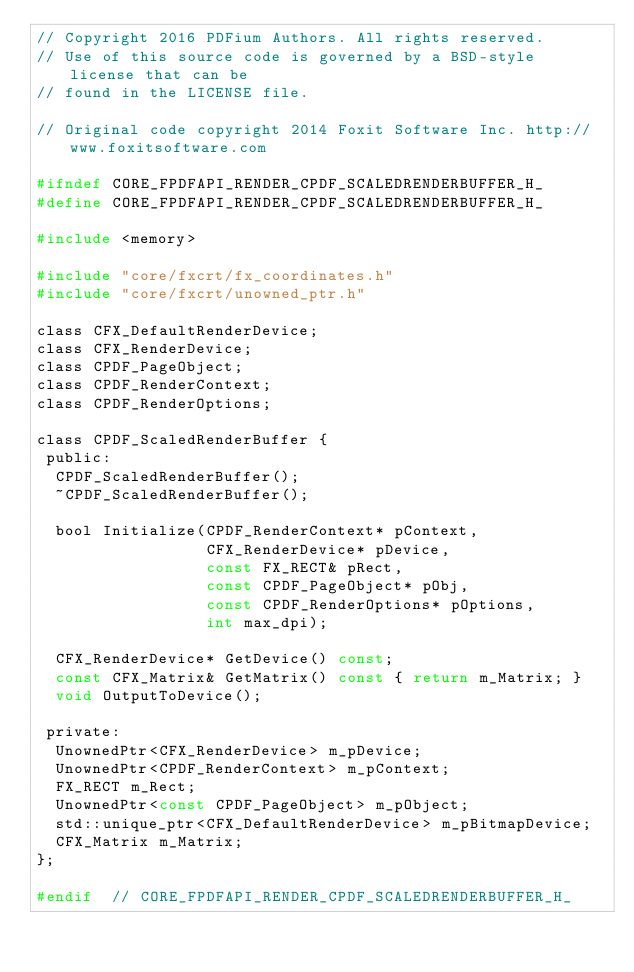Convert code to text. <code><loc_0><loc_0><loc_500><loc_500><_C_>// Copyright 2016 PDFium Authors. All rights reserved.
// Use of this source code is governed by a BSD-style license that can be
// found in the LICENSE file.

// Original code copyright 2014 Foxit Software Inc. http://www.foxitsoftware.com

#ifndef CORE_FPDFAPI_RENDER_CPDF_SCALEDRENDERBUFFER_H_
#define CORE_FPDFAPI_RENDER_CPDF_SCALEDRENDERBUFFER_H_

#include <memory>

#include "core/fxcrt/fx_coordinates.h"
#include "core/fxcrt/unowned_ptr.h"

class CFX_DefaultRenderDevice;
class CFX_RenderDevice;
class CPDF_PageObject;
class CPDF_RenderContext;
class CPDF_RenderOptions;

class CPDF_ScaledRenderBuffer {
 public:
  CPDF_ScaledRenderBuffer();
  ~CPDF_ScaledRenderBuffer();

  bool Initialize(CPDF_RenderContext* pContext,
                  CFX_RenderDevice* pDevice,
                  const FX_RECT& pRect,
                  const CPDF_PageObject* pObj,
                  const CPDF_RenderOptions* pOptions,
                  int max_dpi);

  CFX_RenderDevice* GetDevice() const;
  const CFX_Matrix& GetMatrix() const { return m_Matrix; }
  void OutputToDevice();

 private:
  UnownedPtr<CFX_RenderDevice> m_pDevice;
  UnownedPtr<CPDF_RenderContext> m_pContext;
  FX_RECT m_Rect;
  UnownedPtr<const CPDF_PageObject> m_pObject;
  std::unique_ptr<CFX_DefaultRenderDevice> m_pBitmapDevice;
  CFX_Matrix m_Matrix;
};

#endif  // CORE_FPDFAPI_RENDER_CPDF_SCALEDRENDERBUFFER_H_
</code> 